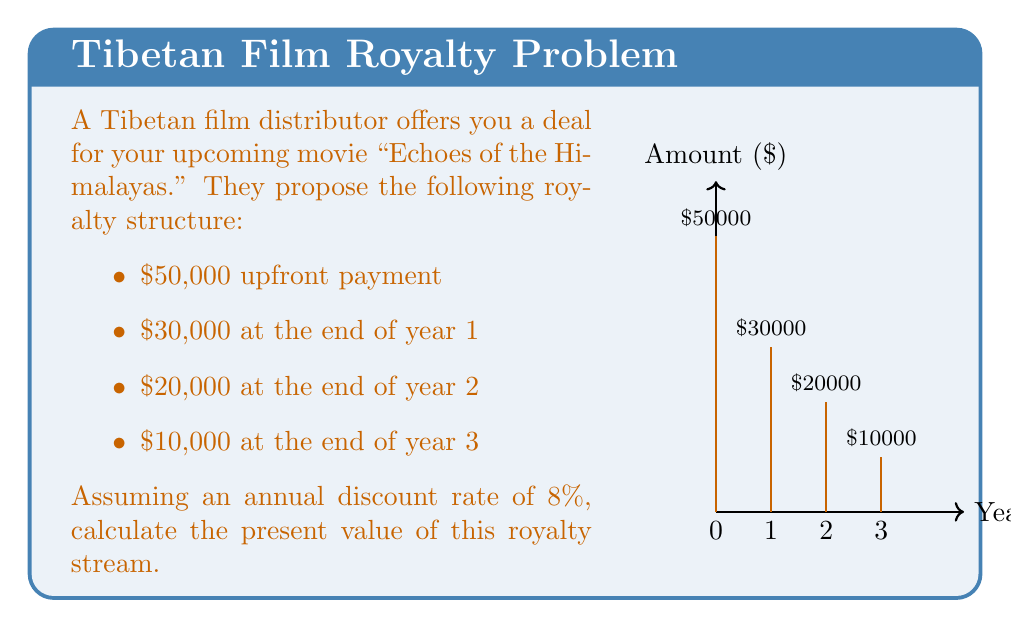Give your solution to this math problem. To calculate the present value of future royalties, we need to discount each future payment back to the present using the given discount rate. The formula for present value is:

$$PV = \frac{FV}{(1+r)^n}$$

Where:
- PV = Present Value
- FV = Future Value
- r = Discount rate
- n = Number of periods

Let's calculate the present value for each payment:

1. Upfront payment ($50,000):
   This is already in present value, so no discounting is needed.
   $PV_0 = $50,000$

2. Year 1 payment ($30,000):
   $$PV_1 = \frac{$30,000}{(1+0.08)^1} = $27,777.78$$

3. Year 2 payment ($20,000):
   $$PV_2 = \frac{$20,000}{(1+0.08)^2} = $17,146.78$$

4. Year 3 payment ($10,000):
   $$PV_3 = \frac{$10,000}{(1+0.08)^3} = $7,938.17$$

Now, we sum up all the present values:

$$Total PV = PV_0 + PV_1 + PV_2 + PV_3$$
$$Total PV = $50,000 + $27,777.78 + $17,146.78 + $7,938.17$$
$$Total PV = $102,862.73$$

Rounding to the nearest dollar, we get $102,863.
Answer: $102,863 